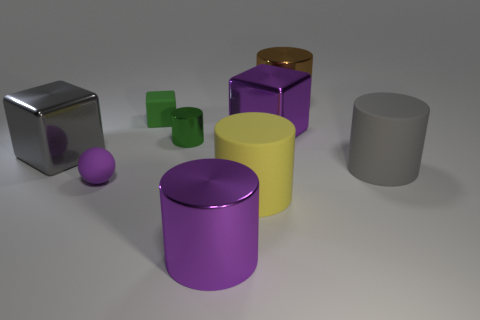There is another thing that is the same color as the tiny metallic object; what is its material?
Offer a terse response. Rubber. What material is the yellow cylinder that is the same size as the purple cylinder?
Ensure brevity in your answer.  Rubber. What is the size of the green thing that is made of the same material as the yellow object?
Provide a succinct answer. Small. Is the number of big objects on the left side of the big yellow cylinder less than the number of tiny green cubes?
Provide a short and direct response. No. There is a large yellow object that is the same material as the small purple object; what is its shape?
Provide a short and direct response. Cylinder. How many other objects are the same shape as the gray matte thing?
Provide a short and direct response. 4. How many yellow things are large metallic cylinders or matte objects?
Offer a very short reply. 1. Is the shape of the small green matte object the same as the large brown object?
Provide a short and direct response. No. Is there a tiny shiny cylinder that is in front of the big gray thing that is behind the large gray cylinder?
Offer a terse response. No. Are there an equal number of small green shiny objects behind the big brown shiny cylinder and brown shiny blocks?
Your answer should be very brief. Yes. 